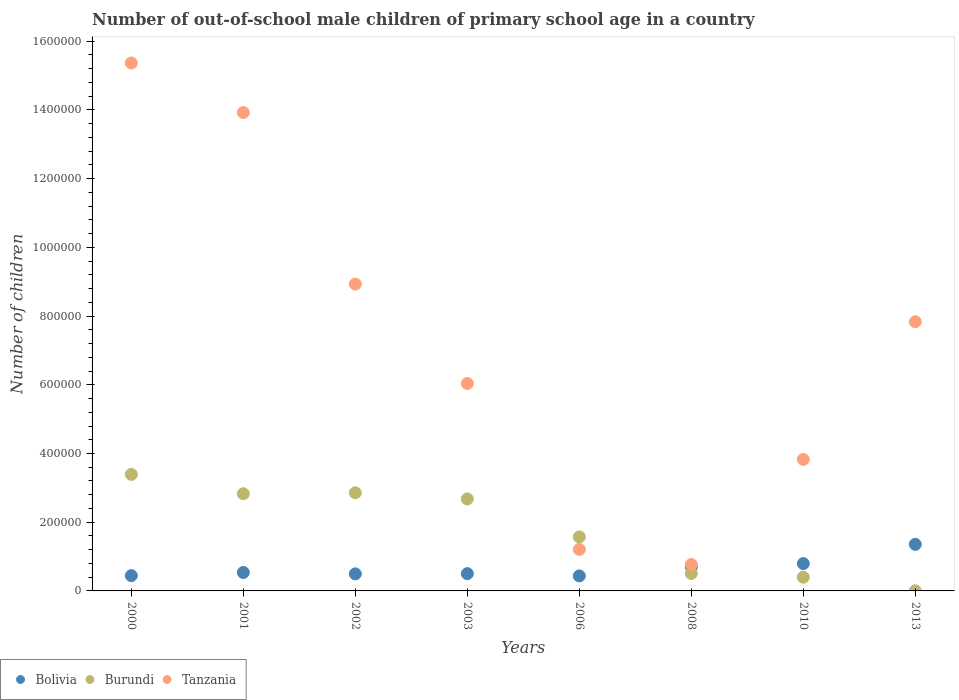Is the number of dotlines equal to the number of legend labels?
Provide a succinct answer. Yes. What is the number of out-of-school male children in Burundi in 2003?
Your answer should be compact. 2.68e+05. Across all years, what is the maximum number of out-of-school male children in Bolivia?
Your answer should be compact. 1.36e+05. Across all years, what is the minimum number of out-of-school male children in Tanzania?
Offer a very short reply. 7.68e+04. In which year was the number of out-of-school male children in Bolivia minimum?
Your answer should be very brief. 2006. What is the total number of out-of-school male children in Bolivia in the graph?
Offer a terse response. 5.27e+05. What is the difference between the number of out-of-school male children in Tanzania in 2002 and that in 2010?
Your answer should be compact. 5.10e+05. What is the difference between the number of out-of-school male children in Tanzania in 2001 and the number of out-of-school male children in Bolivia in 2010?
Your response must be concise. 1.31e+06. What is the average number of out-of-school male children in Burundi per year?
Your answer should be compact. 1.78e+05. In the year 2000, what is the difference between the number of out-of-school male children in Bolivia and number of out-of-school male children in Burundi?
Offer a terse response. -2.95e+05. What is the ratio of the number of out-of-school male children in Tanzania in 2000 to that in 2002?
Your response must be concise. 1.72. Is the number of out-of-school male children in Tanzania in 2003 less than that in 2008?
Your answer should be very brief. No. What is the difference between the highest and the second highest number of out-of-school male children in Bolivia?
Ensure brevity in your answer.  5.60e+04. What is the difference between the highest and the lowest number of out-of-school male children in Tanzania?
Your answer should be compact. 1.46e+06. Is the sum of the number of out-of-school male children in Burundi in 2001 and 2002 greater than the maximum number of out-of-school male children in Bolivia across all years?
Your response must be concise. Yes. Is it the case that in every year, the sum of the number of out-of-school male children in Bolivia and number of out-of-school male children in Tanzania  is greater than the number of out-of-school male children in Burundi?
Your answer should be compact. Yes. Is the number of out-of-school male children in Bolivia strictly greater than the number of out-of-school male children in Burundi over the years?
Your response must be concise. No. Are the values on the major ticks of Y-axis written in scientific E-notation?
Your answer should be very brief. No. Does the graph contain grids?
Give a very brief answer. No. How many legend labels are there?
Provide a succinct answer. 3. What is the title of the graph?
Provide a succinct answer. Number of out-of-school male children of primary school age in a country. Does "Other small states" appear as one of the legend labels in the graph?
Your answer should be very brief. No. What is the label or title of the Y-axis?
Ensure brevity in your answer.  Number of children. What is the Number of children of Bolivia in 2000?
Offer a terse response. 4.45e+04. What is the Number of children of Burundi in 2000?
Offer a terse response. 3.39e+05. What is the Number of children of Tanzania in 2000?
Provide a short and direct response. 1.54e+06. What is the Number of children in Bolivia in 2001?
Your answer should be very brief. 5.37e+04. What is the Number of children in Burundi in 2001?
Give a very brief answer. 2.83e+05. What is the Number of children in Tanzania in 2001?
Provide a succinct answer. 1.39e+06. What is the Number of children of Bolivia in 2002?
Your response must be concise. 4.96e+04. What is the Number of children of Burundi in 2002?
Provide a short and direct response. 2.86e+05. What is the Number of children of Tanzania in 2002?
Offer a terse response. 8.93e+05. What is the Number of children of Bolivia in 2003?
Your answer should be compact. 5.03e+04. What is the Number of children of Burundi in 2003?
Give a very brief answer. 2.68e+05. What is the Number of children in Tanzania in 2003?
Your response must be concise. 6.04e+05. What is the Number of children of Bolivia in 2006?
Offer a very short reply. 4.37e+04. What is the Number of children in Burundi in 2006?
Offer a very short reply. 1.57e+05. What is the Number of children of Tanzania in 2006?
Offer a very short reply. 1.21e+05. What is the Number of children of Bolivia in 2008?
Keep it short and to the point. 7.06e+04. What is the Number of children in Burundi in 2008?
Your answer should be compact. 5.05e+04. What is the Number of children in Tanzania in 2008?
Make the answer very short. 7.68e+04. What is the Number of children of Bolivia in 2010?
Provide a succinct answer. 7.95e+04. What is the Number of children of Burundi in 2010?
Provide a succinct answer. 3.99e+04. What is the Number of children in Tanzania in 2010?
Ensure brevity in your answer.  3.83e+05. What is the Number of children in Bolivia in 2013?
Keep it short and to the point. 1.36e+05. What is the Number of children of Burundi in 2013?
Keep it short and to the point. 326. What is the Number of children in Tanzania in 2013?
Provide a short and direct response. 7.83e+05. Across all years, what is the maximum Number of children in Bolivia?
Give a very brief answer. 1.36e+05. Across all years, what is the maximum Number of children in Burundi?
Make the answer very short. 3.39e+05. Across all years, what is the maximum Number of children of Tanzania?
Ensure brevity in your answer.  1.54e+06. Across all years, what is the minimum Number of children in Bolivia?
Your answer should be compact. 4.37e+04. Across all years, what is the minimum Number of children of Burundi?
Provide a short and direct response. 326. Across all years, what is the minimum Number of children in Tanzania?
Your answer should be very brief. 7.68e+04. What is the total Number of children of Bolivia in the graph?
Provide a succinct answer. 5.27e+05. What is the total Number of children in Burundi in the graph?
Provide a short and direct response. 1.42e+06. What is the total Number of children in Tanzania in the graph?
Offer a terse response. 5.79e+06. What is the difference between the Number of children in Bolivia in 2000 and that in 2001?
Your response must be concise. -9210. What is the difference between the Number of children in Burundi in 2000 and that in 2001?
Provide a short and direct response. 5.63e+04. What is the difference between the Number of children of Tanzania in 2000 and that in 2001?
Provide a succinct answer. 1.44e+05. What is the difference between the Number of children in Bolivia in 2000 and that in 2002?
Make the answer very short. -5108. What is the difference between the Number of children of Burundi in 2000 and that in 2002?
Provide a short and direct response. 5.35e+04. What is the difference between the Number of children of Tanzania in 2000 and that in 2002?
Provide a short and direct response. 6.44e+05. What is the difference between the Number of children of Bolivia in 2000 and that in 2003?
Make the answer very short. -5820. What is the difference between the Number of children of Burundi in 2000 and that in 2003?
Give a very brief answer. 7.14e+04. What is the difference between the Number of children in Tanzania in 2000 and that in 2003?
Keep it short and to the point. 9.33e+05. What is the difference between the Number of children in Bolivia in 2000 and that in 2006?
Keep it short and to the point. 796. What is the difference between the Number of children of Burundi in 2000 and that in 2006?
Your answer should be very brief. 1.82e+05. What is the difference between the Number of children of Tanzania in 2000 and that in 2006?
Offer a very short reply. 1.42e+06. What is the difference between the Number of children of Bolivia in 2000 and that in 2008?
Your response must be concise. -2.61e+04. What is the difference between the Number of children of Burundi in 2000 and that in 2008?
Make the answer very short. 2.89e+05. What is the difference between the Number of children of Tanzania in 2000 and that in 2008?
Your answer should be compact. 1.46e+06. What is the difference between the Number of children of Bolivia in 2000 and that in 2010?
Give a very brief answer. -3.51e+04. What is the difference between the Number of children in Burundi in 2000 and that in 2010?
Make the answer very short. 2.99e+05. What is the difference between the Number of children in Tanzania in 2000 and that in 2010?
Your answer should be compact. 1.15e+06. What is the difference between the Number of children in Bolivia in 2000 and that in 2013?
Provide a short and direct response. -9.11e+04. What is the difference between the Number of children in Burundi in 2000 and that in 2013?
Give a very brief answer. 3.39e+05. What is the difference between the Number of children of Tanzania in 2000 and that in 2013?
Keep it short and to the point. 7.53e+05. What is the difference between the Number of children of Bolivia in 2001 and that in 2002?
Offer a terse response. 4102. What is the difference between the Number of children of Burundi in 2001 and that in 2002?
Provide a short and direct response. -2820. What is the difference between the Number of children of Tanzania in 2001 and that in 2002?
Make the answer very short. 4.99e+05. What is the difference between the Number of children in Bolivia in 2001 and that in 2003?
Your answer should be compact. 3390. What is the difference between the Number of children of Burundi in 2001 and that in 2003?
Your response must be concise. 1.51e+04. What is the difference between the Number of children of Tanzania in 2001 and that in 2003?
Offer a very short reply. 7.89e+05. What is the difference between the Number of children of Bolivia in 2001 and that in 2006?
Offer a very short reply. 1.00e+04. What is the difference between the Number of children of Burundi in 2001 and that in 2006?
Give a very brief answer. 1.26e+05. What is the difference between the Number of children of Tanzania in 2001 and that in 2006?
Give a very brief answer. 1.27e+06. What is the difference between the Number of children in Bolivia in 2001 and that in 2008?
Ensure brevity in your answer.  -1.69e+04. What is the difference between the Number of children of Burundi in 2001 and that in 2008?
Keep it short and to the point. 2.32e+05. What is the difference between the Number of children in Tanzania in 2001 and that in 2008?
Provide a succinct answer. 1.32e+06. What is the difference between the Number of children of Bolivia in 2001 and that in 2010?
Provide a short and direct response. -2.59e+04. What is the difference between the Number of children in Burundi in 2001 and that in 2010?
Offer a very short reply. 2.43e+05. What is the difference between the Number of children of Tanzania in 2001 and that in 2010?
Ensure brevity in your answer.  1.01e+06. What is the difference between the Number of children in Bolivia in 2001 and that in 2013?
Your answer should be compact. -8.19e+04. What is the difference between the Number of children in Burundi in 2001 and that in 2013?
Ensure brevity in your answer.  2.83e+05. What is the difference between the Number of children of Tanzania in 2001 and that in 2013?
Offer a terse response. 6.09e+05. What is the difference between the Number of children of Bolivia in 2002 and that in 2003?
Your answer should be very brief. -712. What is the difference between the Number of children of Burundi in 2002 and that in 2003?
Your answer should be compact. 1.79e+04. What is the difference between the Number of children in Tanzania in 2002 and that in 2003?
Give a very brief answer. 2.89e+05. What is the difference between the Number of children of Bolivia in 2002 and that in 2006?
Keep it short and to the point. 5904. What is the difference between the Number of children of Burundi in 2002 and that in 2006?
Keep it short and to the point. 1.28e+05. What is the difference between the Number of children of Tanzania in 2002 and that in 2006?
Make the answer very short. 7.72e+05. What is the difference between the Number of children of Bolivia in 2002 and that in 2008?
Keep it short and to the point. -2.10e+04. What is the difference between the Number of children of Burundi in 2002 and that in 2008?
Give a very brief answer. 2.35e+05. What is the difference between the Number of children of Tanzania in 2002 and that in 2008?
Keep it short and to the point. 8.16e+05. What is the difference between the Number of children of Bolivia in 2002 and that in 2010?
Offer a very short reply. -3.00e+04. What is the difference between the Number of children in Burundi in 2002 and that in 2010?
Your answer should be very brief. 2.46e+05. What is the difference between the Number of children of Tanzania in 2002 and that in 2010?
Make the answer very short. 5.10e+05. What is the difference between the Number of children of Bolivia in 2002 and that in 2013?
Ensure brevity in your answer.  -8.60e+04. What is the difference between the Number of children of Burundi in 2002 and that in 2013?
Offer a very short reply. 2.85e+05. What is the difference between the Number of children of Tanzania in 2002 and that in 2013?
Give a very brief answer. 1.10e+05. What is the difference between the Number of children in Bolivia in 2003 and that in 2006?
Provide a succinct answer. 6616. What is the difference between the Number of children of Burundi in 2003 and that in 2006?
Keep it short and to the point. 1.10e+05. What is the difference between the Number of children in Tanzania in 2003 and that in 2006?
Keep it short and to the point. 4.83e+05. What is the difference between the Number of children in Bolivia in 2003 and that in 2008?
Your answer should be compact. -2.03e+04. What is the difference between the Number of children in Burundi in 2003 and that in 2008?
Your response must be concise. 2.17e+05. What is the difference between the Number of children in Tanzania in 2003 and that in 2008?
Offer a very short reply. 5.27e+05. What is the difference between the Number of children of Bolivia in 2003 and that in 2010?
Ensure brevity in your answer.  -2.92e+04. What is the difference between the Number of children of Burundi in 2003 and that in 2010?
Offer a very short reply. 2.28e+05. What is the difference between the Number of children of Tanzania in 2003 and that in 2010?
Ensure brevity in your answer.  2.21e+05. What is the difference between the Number of children of Bolivia in 2003 and that in 2013?
Give a very brief answer. -8.53e+04. What is the difference between the Number of children of Burundi in 2003 and that in 2013?
Your answer should be very brief. 2.67e+05. What is the difference between the Number of children in Tanzania in 2003 and that in 2013?
Give a very brief answer. -1.80e+05. What is the difference between the Number of children of Bolivia in 2006 and that in 2008?
Give a very brief answer. -2.69e+04. What is the difference between the Number of children of Burundi in 2006 and that in 2008?
Give a very brief answer. 1.07e+05. What is the difference between the Number of children in Tanzania in 2006 and that in 2008?
Give a very brief answer. 4.40e+04. What is the difference between the Number of children of Bolivia in 2006 and that in 2010?
Offer a very short reply. -3.59e+04. What is the difference between the Number of children in Burundi in 2006 and that in 2010?
Offer a terse response. 1.17e+05. What is the difference between the Number of children in Tanzania in 2006 and that in 2010?
Provide a succinct answer. -2.62e+05. What is the difference between the Number of children in Bolivia in 2006 and that in 2013?
Make the answer very short. -9.19e+04. What is the difference between the Number of children in Burundi in 2006 and that in 2013?
Your answer should be compact. 1.57e+05. What is the difference between the Number of children in Tanzania in 2006 and that in 2013?
Keep it short and to the point. -6.63e+05. What is the difference between the Number of children of Bolivia in 2008 and that in 2010?
Your response must be concise. -8972. What is the difference between the Number of children in Burundi in 2008 and that in 2010?
Offer a terse response. 1.06e+04. What is the difference between the Number of children in Tanzania in 2008 and that in 2010?
Your answer should be compact. -3.06e+05. What is the difference between the Number of children in Bolivia in 2008 and that in 2013?
Ensure brevity in your answer.  -6.50e+04. What is the difference between the Number of children in Burundi in 2008 and that in 2013?
Give a very brief answer. 5.02e+04. What is the difference between the Number of children of Tanzania in 2008 and that in 2013?
Keep it short and to the point. -7.07e+05. What is the difference between the Number of children in Bolivia in 2010 and that in 2013?
Your answer should be very brief. -5.60e+04. What is the difference between the Number of children in Burundi in 2010 and that in 2013?
Provide a short and direct response. 3.96e+04. What is the difference between the Number of children of Tanzania in 2010 and that in 2013?
Give a very brief answer. -4.01e+05. What is the difference between the Number of children in Bolivia in 2000 and the Number of children in Burundi in 2001?
Give a very brief answer. -2.38e+05. What is the difference between the Number of children of Bolivia in 2000 and the Number of children of Tanzania in 2001?
Offer a very short reply. -1.35e+06. What is the difference between the Number of children of Burundi in 2000 and the Number of children of Tanzania in 2001?
Give a very brief answer. -1.05e+06. What is the difference between the Number of children in Bolivia in 2000 and the Number of children in Burundi in 2002?
Make the answer very short. -2.41e+05. What is the difference between the Number of children in Bolivia in 2000 and the Number of children in Tanzania in 2002?
Your answer should be very brief. -8.49e+05. What is the difference between the Number of children in Burundi in 2000 and the Number of children in Tanzania in 2002?
Your answer should be very brief. -5.54e+05. What is the difference between the Number of children of Bolivia in 2000 and the Number of children of Burundi in 2003?
Provide a short and direct response. -2.23e+05. What is the difference between the Number of children in Bolivia in 2000 and the Number of children in Tanzania in 2003?
Offer a very short reply. -5.59e+05. What is the difference between the Number of children in Burundi in 2000 and the Number of children in Tanzania in 2003?
Keep it short and to the point. -2.65e+05. What is the difference between the Number of children in Bolivia in 2000 and the Number of children in Burundi in 2006?
Keep it short and to the point. -1.13e+05. What is the difference between the Number of children of Bolivia in 2000 and the Number of children of Tanzania in 2006?
Make the answer very short. -7.63e+04. What is the difference between the Number of children in Burundi in 2000 and the Number of children in Tanzania in 2006?
Keep it short and to the point. 2.18e+05. What is the difference between the Number of children in Bolivia in 2000 and the Number of children in Burundi in 2008?
Make the answer very short. -6035. What is the difference between the Number of children of Bolivia in 2000 and the Number of children of Tanzania in 2008?
Offer a terse response. -3.24e+04. What is the difference between the Number of children in Burundi in 2000 and the Number of children in Tanzania in 2008?
Ensure brevity in your answer.  2.62e+05. What is the difference between the Number of children in Bolivia in 2000 and the Number of children in Burundi in 2010?
Your answer should be very brief. 4585. What is the difference between the Number of children in Bolivia in 2000 and the Number of children in Tanzania in 2010?
Offer a terse response. -3.38e+05. What is the difference between the Number of children in Burundi in 2000 and the Number of children in Tanzania in 2010?
Keep it short and to the point. -4.36e+04. What is the difference between the Number of children of Bolivia in 2000 and the Number of children of Burundi in 2013?
Make the answer very short. 4.41e+04. What is the difference between the Number of children in Bolivia in 2000 and the Number of children in Tanzania in 2013?
Make the answer very short. -7.39e+05. What is the difference between the Number of children of Burundi in 2000 and the Number of children of Tanzania in 2013?
Provide a short and direct response. -4.44e+05. What is the difference between the Number of children of Bolivia in 2001 and the Number of children of Burundi in 2002?
Provide a short and direct response. -2.32e+05. What is the difference between the Number of children of Bolivia in 2001 and the Number of children of Tanzania in 2002?
Provide a short and direct response. -8.39e+05. What is the difference between the Number of children of Burundi in 2001 and the Number of children of Tanzania in 2002?
Your answer should be very brief. -6.10e+05. What is the difference between the Number of children of Bolivia in 2001 and the Number of children of Burundi in 2003?
Provide a short and direct response. -2.14e+05. What is the difference between the Number of children in Bolivia in 2001 and the Number of children in Tanzania in 2003?
Keep it short and to the point. -5.50e+05. What is the difference between the Number of children of Burundi in 2001 and the Number of children of Tanzania in 2003?
Make the answer very short. -3.21e+05. What is the difference between the Number of children of Bolivia in 2001 and the Number of children of Burundi in 2006?
Your response must be concise. -1.04e+05. What is the difference between the Number of children of Bolivia in 2001 and the Number of children of Tanzania in 2006?
Your answer should be compact. -6.71e+04. What is the difference between the Number of children of Burundi in 2001 and the Number of children of Tanzania in 2006?
Your answer should be very brief. 1.62e+05. What is the difference between the Number of children of Bolivia in 2001 and the Number of children of Burundi in 2008?
Your response must be concise. 3175. What is the difference between the Number of children of Bolivia in 2001 and the Number of children of Tanzania in 2008?
Your answer should be compact. -2.32e+04. What is the difference between the Number of children in Burundi in 2001 and the Number of children in Tanzania in 2008?
Make the answer very short. 2.06e+05. What is the difference between the Number of children in Bolivia in 2001 and the Number of children in Burundi in 2010?
Give a very brief answer. 1.38e+04. What is the difference between the Number of children of Bolivia in 2001 and the Number of children of Tanzania in 2010?
Offer a very short reply. -3.29e+05. What is the difference between the Number of children in Burundi in 2001 and the Number of children in Tanzania in 2010?
Your response must be concise. -9.99e+04. What is the difference between the Number of children in Bolivia in 2001 and the Number of children in Burundi in 2013?
Keep it short and to the point. 5.34e+04. What is the difference between the Number of children in Bolivia in 2001 and the Number of children in Tanzania in 2013?
Keep it short and to the point. -7.30e+05. What is the difference between the Number of children in Burundi in 2001 and the Number of children in Tanzania in 2013?
Your answer should be compact. -5.01e+05. What is the difference between the Number of children in Bolivia in 2002 and the Number of children in Burundi in 2003?
Your answer should be compact. -2.18e+05. What is the difference between the Number of children in Bolivia in 2002 and the Number of children in Tanzania in 2003?
Provide a short and direct response. -5.54e+05. What is the difference between the Number of children in Burundi in 2002 and the Number of children in Tanzania in 2003?
Your response must be concise. -3.18e+05. What is the difference between the Number of children in Bolivia in 2002 and the Number of children in Burundi in 2006?
Your response must be concise. -1.08e+05. What is the difference between the Number of children of Bolivia in 2002 and the Number of children of Tanzania in 2006?
Provide a short and direct response. -7.12e+04. What is the difference between the Number of children in Burundi in 2002 and the Number of children in Tanzania in 2006?
Your answer should be compact. 1.65e+05. What is the difference between the Number of children in Bolivia in 2002 and the Number of children in Burundi in 2008?
Provide a succinct answer. -927. What is the difference between the Number of children in Bolivia in 2002 and the Number of children in Tanzania in 2008?
Provide a succinct answer. -2.73e+04. What is the difference between the Number of children of Burundi in 2002 and the Number of children of Tanzania in 2008?
Your response must be concise. 2.09e+05. What is the difference between the Number of children in Bolivia in 2002 and the Number of children in Burundi in 2010?
Your response must be concise. 9693. What is the difference between the Number of children of Bolivia in 2002 and the Number of children of Tanzania in 2010?
Give a very brief answer. -3.33e+05. What is the difference between the Number of children of Burundi in 2002 and the Number of children of Tanzania in 2010?
Your answer should be very brief. -9.71e+04. What is the difference between the Number of children in Bolivia in 2002 and the Number of children in Burundi in 2013?
Offer a very short reply. 4.93e+04. What is the difference between the Number of children in Bolivia in 2002 and the Number of children in Tanzania in 2013?
Provide a short and direct response. -7.34e+05. What is the difference between the Number of children in Burundi in 2002 and the Number of children in Tanzania in 2013?
Make the answer very short. -4.98e+05. What is the difference between the Number of children of Bolivia in 2003 and the Number of children of Burundi in 2006?
Your response must be concise. -1.07e+05. What is the difference between the Number of children in Bolivia in 2003 and the Number of children in Tanzania in 2006?
Keep it short and to the point. -7.05e+04. What is the difference between the Number of children of Burundi in 2003 and the Number of children of Tanzania in 2006?
Your answer should be compact. 1.47e+05. What is the difference between the Number of children in Bolivia in 2003 and the Number of children in Burundi in 2008?
Ensure brevity in your answer.  -215. What is the difference between the Number of children in Bolivia in 2003 and the Number of children in Tanzania in 2008?
Your response must be concise. -2.66e+04. What is the difference between the Number of children in Burundi in 2003 and the Number of children in Tanzania in 2008?
Provide a succinct answer. 1.91e+05. What is the difference between the Number of children of Bolivia in 2003 and the Number of children of Burundi in 2010?
Provide a succinct answer. 1.04e+04. What is the difference between the Number of children of Bolivia in 2003 and the Number of children of Tanzania in 2010?
Provide a succinct answer. -3.32e+05. What is the difference between the Number of children in Burundi in 2003 and the Number of children in Tanzania in 2010?
Your answer should be very brief. -1.15e+05. What is the difference between the Number of children in Bolivia in 2003 and the Number of children in Burundi in 2013?
Provide a short and direct response. 5.00e+04. What is the difference between the Number of children in Bolivia in 2003 and the Number of children in Tanzania in 2013?
Your answer should be very brief. -7.33e+05. What is the difference between the Number of children of Burundi in 2003 and the Number of children of Tanzania in 2013?
Your response must be concise. -5.16e+05. What is the difference between the Number of children in Bolivia in 2006 and the Number of children in Burundi in 2008?
Give a very brief answer. -6831. What is the difference between the Number of children in Bolivia in 2006 and the Number of children in Tanzania in 2008?
Give a very brief answer. -3.32e+04. What is the difference between the Number of children of Burundi in 2006 and the Number of children of Tanzania in 2008?
Offer a terse response. 8.04e+04. What is the difference between the Number of children in Bolivia in 2006 and the Number of children in Burundi in 2010?
Give a very brief answer. 3789. What is the difference between the Number of children in Bolivia in 2006 and the Number of children in Tanzania in 2010?
Offer a very short reply. -3.39e+05. What is the difference between the Number of children of Burundi in 2006 and the Number of children of Tanzania in 2010?
Give a very brief answer. -2.25e+05. What is the difference between the Number of children of Bolivia in 2006 and the Number of children of Burundi in 2013?
Make the answer very short. 4.34e+04. What is the difference between the Number of children of Bolivia in 2006 and the Number of children of Tanzania in 2013?
Your answer should be compact. -7.40e+05. What is the difference between the Number of children in Burundi in 2006 and the Number of children in Tanzania in 2013?
Ensure brevity in your answer.  -6.26e+05. What is the difference between the Number of children in Bolivia in 2008 and the Number of children in Burundi in 2010?
Keep it short and to the point. 3.07e+04. What is the difference between the Number of children of Bolivia in 2008 and the Number of children of Tanzania in 2010?
Ensure brevity in your answer.  -3.12e+05. What is the difference between the Number of children in Burundi in 2008 and the Number of children in Tanzania in 2010?
Ensure brevity in your answer.  -3.32e+05. What is the difference between the Number of children in Bolivia in 2008 and the Number of children in Burundi in 2013?
Keep it short and to the point. 7.02e+04. What is the difference between the Number of children in Bolivia in 2008 and the Number of children in Tanzania in 2013?
Ensure brevity in your answer.  -7.13e+05. What is the difference between the Number of children in Burundi in 2008 and the Number of children in Tanzania in 2013?
Provide a short and direct response. -7.33e+05. What is the difference between the Number of children in Bolivia in 2010 and the Number of children in Burundi in 2013?
Make the answer very short. 7.92e+04. What is the difference between the Number of children of Bolivia in 2010 and the Number of children of Tanzania in 2013?
Provide a short and direct response. -7.04e+05. What is the difference between the Number of children in Burundi in 2010 and the Number of children in Tanzania in 2013?
Give a very brief answer. -7.44e+05. What is the average Number of children in Bolivia per year?
Offer a terse response. 6.59e+04. What is the average Number of children of Burundi per year?
Provide a short and direct response. 1.78e+05. What is the average Number of children in Tanzania per year?
Your answer should be very brief. 7.24e+05. In the year 2000, what is the difference between the Number of children in Bolivia and Number of children in Burundi?
Offer a very short reply. -2.95e+05. In the year 2000, what is the difference between the Number of children in Bolivia and Number of children in Tanzania?
Provide a short and direct response. -1.49e+06. In the year 2000, what is the difference between the Number of children in Burundi and Number of children in Tanzania?
Your answer should be very brief. -1.20e+06. In the year 2001, what is the difference between the Number of children of Bolivia and Number of children of Burundi?
Ensure brevity in your answer.  -2.29e+05. In the year 2001, what is the difference between the Number of children of Bolivia and Number of children of Tanzania?
Your response must be concise. -1.34e+06. In the year 2001, what is the difference between the Number of children in Burundi and Number of children in Tanzania?
Your answer should be very brief. -1.11e+06. In the year 2002, what is the difference between the Number of children in Bolivia and Number of children in Burundi?
Keep it short and to the point. -2.36e+05. In the year 2002, what is the difference between the Number of children of Bolivia and Number of children of Tanzania?
Offer a very short reply. -8.43e+05. In the year 2002, what is the difference between the Number of children in Burundi and Number of children in Tanzania?
Your response must be concise. -6.07e+05. In the year 2003, what is the difference between the Number of children in Bolivia and Number of children in Burundi?
Ensure brevity in your answer.  -2.17e+05. In the year 2003, what is the difference between the Number of children in Bolivia and Number of children in Tanzania?
Provide a short and direct response. -5.53e+05. In the year 2003, what is the difference between the Number of children in Burundi and Number of children in Tanzania?
Your answer should be compact. -3.36e+05. In the year 2006, what is the difference between the Number of children in Bolivia and Number of children in Burundi?
Provide a succinct answer. -1.14e+05. In the year 2006, what is the difference between the Number of children in Bolivia and Number of children in Tanzania?
Provide a succinct answer. -7.71e+04. In the year 2006, what is the difference between the Number of children in Burundi and Number of children in Tanzania?
Your answer should be compact. 3.65e+04. In the year 2008, what is the difference between the Number of children in Bolivia and Number of children in Burundi?
Ensure brevity in your answer.  2.01e+04. In the year 2008, what is the difference between the Number of children of Bolivia and Number of children of Tanzania?
Your answer should be very brief. -6273. In the year 2008, what is the difference between the Number of children in Burundi and Number of children in Tanzania?
Make the answer very short. -2.63e+04. In the year 2010, what is the difference between the Number of children of Bolivia and Number of children of Burundi?
Give a very brief answer. 3.97e+04. In the year 2010, what is the difference between the Number of children in Bolivia and Number of children in Tanzania?
Your answer should be very brief. -3.03e+05. In the year 2010, what is the difference between the Number of children in Burundi and Number of children in Tanzania?
Keep it short and to the point. -3.43e+05. In the year 2013, what is the difference between the Number of children of Bolivia and Number of children of Burundi?
Make the answer very short. 1.35e+05. In the year 2013, what is the difference between the Number of children of Bolivia and Number of children of Tanzania?
Your answer should be very brief. -6.48e+05. In the year 2013, what is the difference between the Number of children of Burundi and Number of children of Tanzania?
Your response must be concise. -7.83e+05. What is the ratio of the Number of children of Bolivia in 2000 to that in 2001?
Your response must be concise. 0.83. What is the ratio of the Number of children of Burundi in 2000 to that in 2001?
Keep it short and to the point. 1.2. What is the ratio of the Number of children in Tanzania in 2000 to that in 2001?
Provide a succinct answer. 1.1. What is the ratio of the Number of children in Bolivia in 2000 to that in 2002?
Your answer should be compact. 0.9. What is the ratio of the Number of children in Burundi in 2000 to that in 2002?
Your answer should be very brief. 1.19. What is the ratio of the Number of children of Tanzania in 2000 to that in 2002?
Your answer should be compact. 1.72. What is the ratio of the Number of children in Bolivia in 2000 to that in 2003?
Offer a very short reply. 0.88. What is the ratio of the Number of children of Burundi in 2000 to that in 2003?
Give a very brief answer. 1.27. What is the ratio of the Number of children in Tanzania in 2000 to that in 2003?
Ensure brevity in your answer.  2.55. What is the ratio of the Number of children in Bolivia in 2000 to that in 2006?
Offer a terse response. 1.02. What is the ratio of the Number of children in Burundi in 2000 to that in 2006?
Your answer should be very brief. 2.16. What is the ratio of the Number of children in Tanzania in 2000 to that in 2006?
Provide a short and direct response. 12.72. What is the ratio of the Number of children of Bolivia in 2000 to that in 2008?
Provide a short and direct response. 0.63. What is the ratio of the Number of children in Burundi in 2000 to that in 2008?
Offer a terse response. 6.72. What is the ratio of the Number of children of Tanzania in 2000 to that in 2008?
Offer a very short reply. 20. What is the ratio of the Number of children in Bolivia in 2000 to that in 2010?
Provide a short and direct response. 0.56. What is the ratio of the Number of children of Burundi in 2000 to that in 2010?
Your answer should be compact. 8.5. What is the ratio of the Number of children of Tanzania in 2000 to that in 2010?
Offer a terse response. 4.01. What is the ratio of the Number of children of Bolivia in 2000 to that in 2013?
Keep it short and to the point. 0.33. What is the ratio of the Number of children of Burundi in 2000 to that in 2013?
Keep it short and to the point. 1040.37. What is the ratio of the Number of children in Tanzania in 2000 to that in 2013?
Offer a terse response. 1.96. What is the ratio of the Number of children in Bolivia in 2001 to that in 2002?
Make the answer very short. 1.08. What is the ratio of the Number of children in Tanzania in 2001 to that in 2002?
Provide a succinct answer. 1.56. What is the ratio of the Number of children of Bolivia in 2001 to that in 2003?
Offer a very short reply. 1.07. What is the ratio of the Number of children in Burundi in 2001 to that in 2003?
Offer a very short reply. 1.06. What is the ratio of the Number of children in Tanzania in 2001 to that in 2003?
Give a very brief answer. 2.31. What is the ratio of the Number of children of Bolivia in 2001 to that in 2006?
Provide a short and direct response. 1.23. What is the ratio of the Number of children of Burundi in 2001 to that in 2006?
Provide a short and direct response. 1.8. What is the ratio of the Number of children in Tanzania in 2001 to that in 2006?
Your answer should be compact. 11.53. What is the ratio of the Number of children of Bolivia in 2001 to that in 2008?
Ensure brevity in your answer.  0.76. What is the ratio of the Number of children in Burundi in 2001 to that in 2008?
Keep it short and to the point. 5.6. What is the ratio of the Number of children of Tanzania in 2001 to that in 2008?
Offer a very short reply. 18.12. What is the ratio of the Number of children of Bolivia in 2001 to that in 2010?
Your answer should be compact. 0.67. What is the ratio of the Number of children in Burundi in 2001 to that in 2010?
Ensure brevity in your answer.  7.09. What is the ratio of the Number of children of Tanzania in 2001 to that in 2010?
Give a very brief answer. 3.64. What is the ratio of the Number of children in Bolivia in 2001 to that in 2013?
Offer a very short reply. 0.4. What is the ratio of the Number of children in Burundi in 2001 to that in 2013?
Make the answer very short. 867.66. What is the ratio of the Number of children in Tanzania in 2001 to that in 2013?
Offer a terse response. 1.78. What is the ratio of the Number of children in Bolivia in 2002 to that in 2003?
Your response must be concise. 0.99. What is the ratio of the Number of children in Burundi in 2002 to that in 2003?
Provide a short and direct response. 1.07. What is the ratio of the Number of children in Tanzania in 2002 to that in 2003?
Your answer should be very brief. 1.48. What is the ratio of the Number of children of Bolivia in 2002 to that in 2006?
Offer a terse response. 1.14. What is the ratio of the Number of children in Burundi in 2002 to that in 2006?
Your answer should be very brief. 1.82. What is the ratio of the Number of children of Tanzania in 2002 to that in 2006?
Offer a terse response. 7.39. What is the ratio of the Number of children of Bolivia in 2002 to that in 2008?
Provide a short and direct response. 0.7. What is the ratio of the Number of children of Burundi in 2002 to that in 2008?
Offer a very short reply. 5.66. What is the ratio of the Number of children in Tanzania in 2002 to that in 2008?
Offer a terse response. 11.62. What is the ratio of the Number of children of Bolivia in 2002 to that in 2010?
Give a very brief answer. 0.62. What is the ratio of the Number of children of Burundi in 2002 to that in 2010?
Offer a very short reply. 7.16. What is the ratio of the Number of children of Tanzania in 2002 to that in 2010?
Your answer should be very brief. 2.33. What is the ratio of the Number of children of Bolivia in 2002 to that in 2013?
Keep it short and to the point. 0.37. What is the ratio of the Number of children in Burundi in 2002 to that in 2013?
Make the answer very short. 876.31. What is the ratio of the Number of children of Tanzania in 2002 to that in 2013?
Provide a short and direct response. 1.14. What is the ratio of the Number of children in Bolivia in 2003 to that in 2006?
Your answer should be compact. 1.15. What is the ratio of the Number of children in Burundi in 2003 to that in 2006?
Keep it short and to the point. 1.7. What is the ratio of the Number of children in Tanzania in 2003 to that in 2006?
Provide a short and direct response. 5. What is the ratio of the Number of children of Bolivia in 2003 to that in 2008?
Your response must be concise. 0.71. What is the ratio of the Number of children of Burundi in 2003 to that in 2008?
Provide a short and direct response. 5.3. What is the ratio of the Number of children of Tanzania in 2003 to that in 2008?
Provide a succinct answer. 7.86. What is the ratio of the Number of children of Bolivia in 2003 to that in 2010?
Keep it short and to the point. 0.63. What is the ratio of the Number of children in Burundi in 2003 to that in 2010?
Offer a terse response. 6.71. What is the ratio of the Number of children in Tanzania in 2003 to that in 2010?
Make the answer very short. 1.58. What is the ratio of the Number of children in Bolivia in 2003 to that in 2013?
Ensure brevity in your answer.  0.37. What is the ratio of the Number of children in Burundi in 2003 to that in 2013?
Your answer should be very brief. 821.31. What is the ratio of the Number of children of Tanzania in 2003 to that in 2013?
Offer a very short reply. 0.77. What is the ratio of the Number of children of Bolivia in 2006 to that in 2008?
Your answer should be very brief. 0.62. What is the ratio of the Number of children of Burundi in 2006 to that in 2008?
Provide a succinct answer. 3.11. What is the ratio of the Number of children of Tanzania in 2006 to that in 2008?
Offer a very short reply. 1.57. What is the ratio of the Number of children of Bolivia in 2006 to that in 2010?
Provide a succinct answer. 0.55. What is the ratio of the Number of children in Burundi in 2006 to that in 2010?
Keep it short and to the point. 3.94. What is the ratio of the Number of children of Tanzania in 2006 to that in 2010?
Your answer should be compact. 0.32. What is the ratio of the Number of children of Bolivia in 2006 to that in 2013?
Keep it short and to the point. 0.32. What is the ratio of the Number of children in Burundi in 2006 to that in 2013?
Your answer should be very brief. 482.44. What is the ratio of the Number of children of Tanzania in 2006 to that in 2013?
Provide a short and direct response. 0.15. What is the ratio of the Number of children in Bolivia in 2008 to that in 2010?
Offer a very short reply. 0.89. What is the ratio of the Number of children in Burundi in 2008 to that in 2010?
Offer a very short reply. 1.27. What is the ratio of the Number of children of Tanzania in 2008 to that in 2010?
Keep it short and to the point. 0.2. What is the ratio of the Number of children in Bolivia in 2008 to that in 2013?
Offer a terse response. 0.52. What is the ratio of the Number of children of Burundi in 2008 to that in 2013?
Offer a very short reply. 154.93. What is the ratio of the Number of children in Tanzania in 2008 to that in 2013?
Provide a succinct answer. 0.1. What is the ratio of the Number of children of Bolivia in 2010 to that in 2013?
Your response must be concise. 0.59. What is the ratio of the Number of children in Burundi in 2010 to that in 2013?
Keep it short and to the point. 122.35. What is the ratio of the Number of children of Tanzania in 2010 to that in 2013?
Give a very brief answer. 0.49. What is the difference between the highest and the second highest Number of children of Bolivia?
Give a very brief answer. 5.60e+04. What is the difference between the highest and the second highest Number of children in Burundi?
Your response must be concise. 5.35e+04. What is the difference between the highest and the second highest Number of children of Tanzania?
Give a very brief answer. 1.44e+05. What is the difference between the highest and the lowest Number of children in Bolivia?
Ensure brevity in your answer.  9.19e+04. What is the difference between the highest and the lowest Number of children in Burundi?
Offer a very short reply. 3.39e+05. What is the difference between the highest and the lowest Number of children of Tanzania?
Your answer should be very brief. 1.46e+06. 